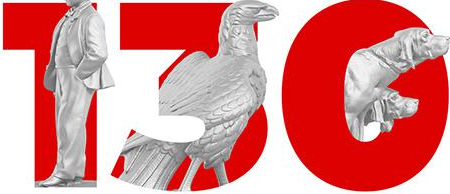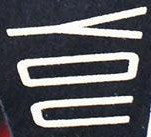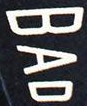What text appears in these images from left to right, separated by a semicolon? 130; YOU; BAD 